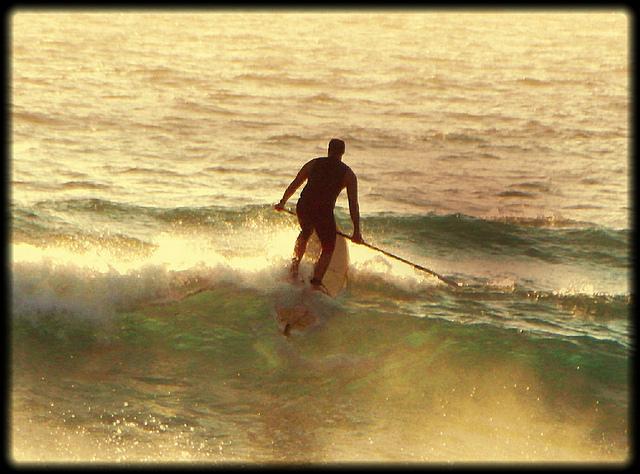Is the man facing the camera?
Be succinct. No. Is that the ocean?
Be succinct. Yes. What is the man doing?
Give a very brief answer. Surfing. 